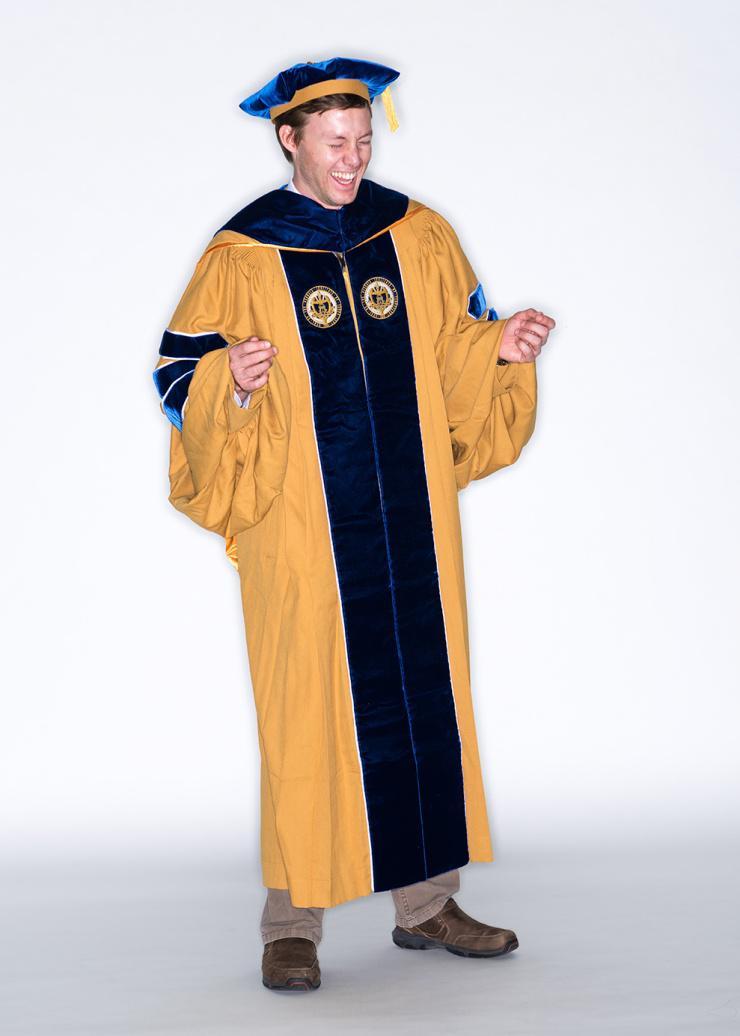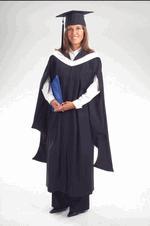The first image is the image on the left, the second image is the image on the right. Given the left and right images, does the statement "An image shows male modeling back and front views of graduation garb." hold true? Answer yes or no. No. The first image is the image on the left, the second image is the image on the right. Considering the images on both sides, is "there is exactly one person in the image on the left" valid? Answer yes or no. Yes. 